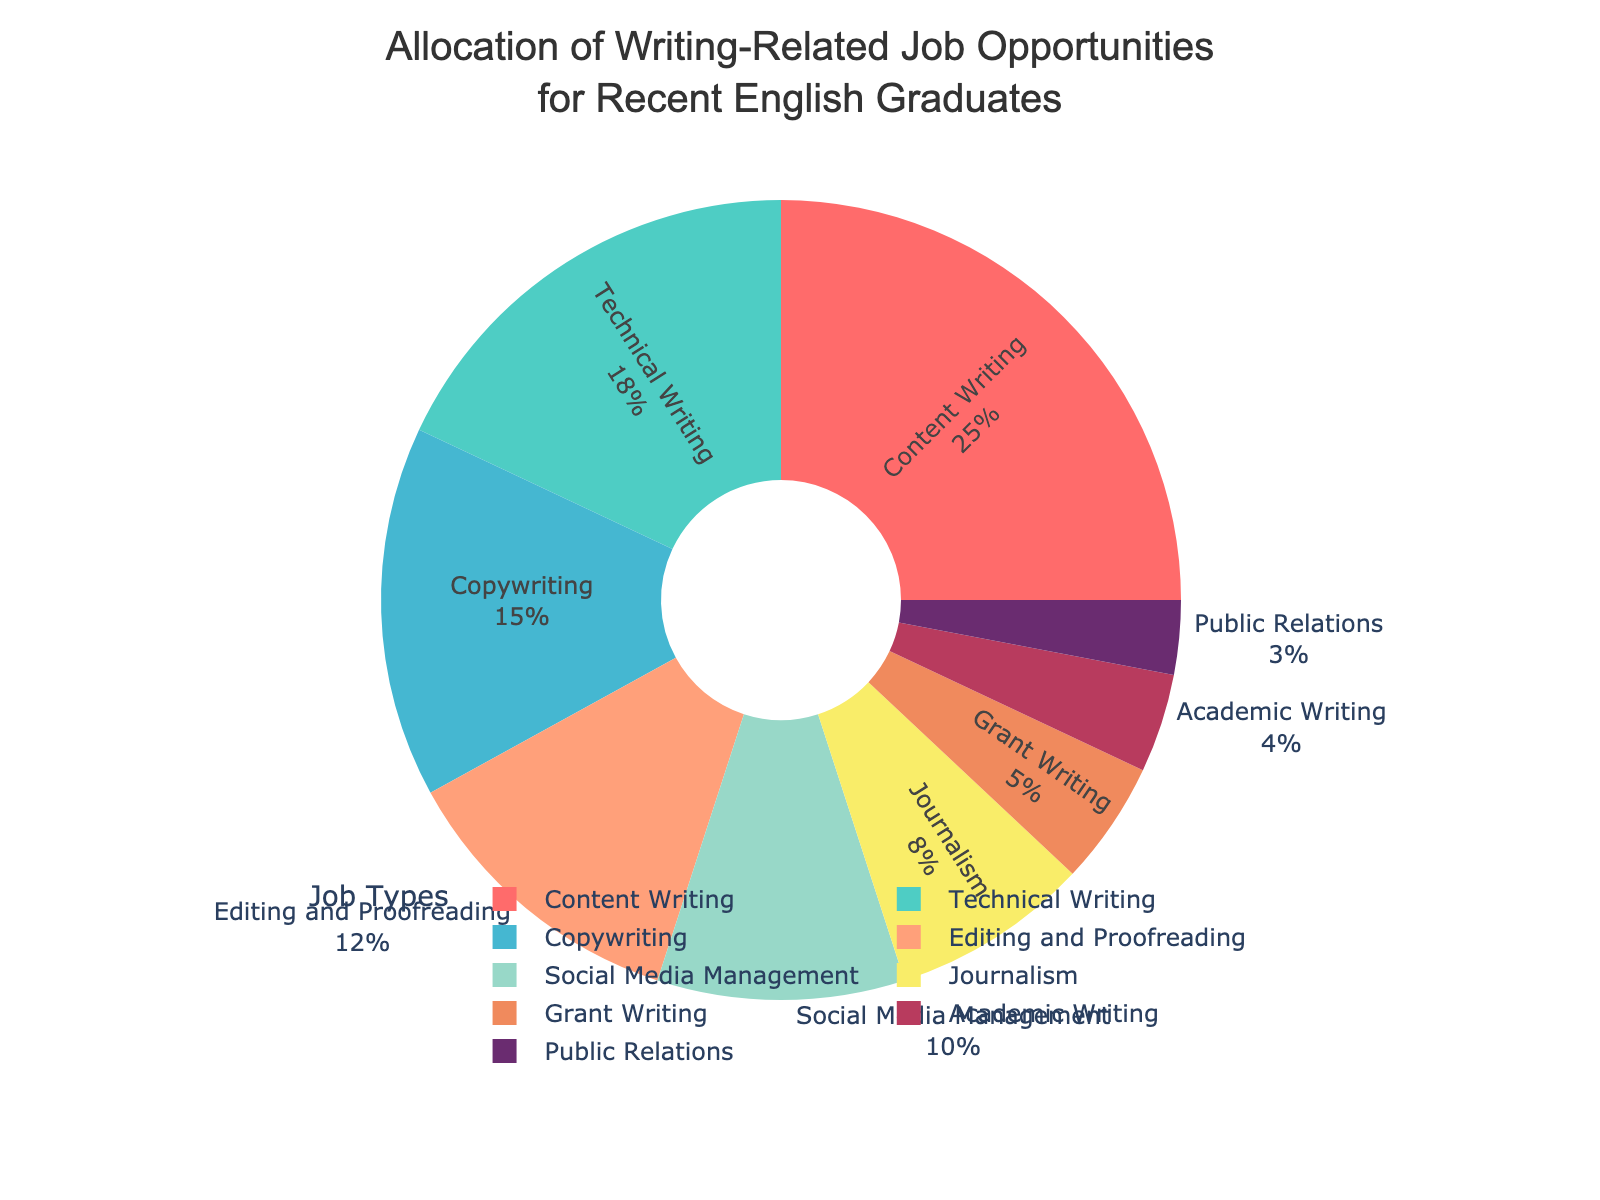Which job type has the highest allocation of opportunities? By looking at the pie chart, the largest segment is visible. The segment labeled "Content Writing" is the largest, indicating that it has the highest allocation.
Answer: Content Writing Which job type has the second highest allocation of opportunities? By observing the pie chart, the second largest segment is clearly labeled "Technical Writing."
Answer: Technical Writing How many job types have an allocation of 10% or more? By examining the pie chart, the segments labeled "Content Writing" (25%), "Technical Writing" (18%), "Copywriting" (15%), and "Editing and Proofreading" (12%) all have allocations of 10% or more. That's 4 job types in total.
Answer: 4 What is the total allocation percentage for jobs in writing and editing (Content Writing + Copywriting + Editing and Proofreading)? Sum the percentages for these job types: Content Writing (25%) + Copywriting (15%) + Editing and Proofreading (12%) = 52%.
Answer: 52% Which job type has the smallest allocation of opportunities? By examining the pie chart, the smallest segment is labeled "Public Relations," indicating that it has the smallest allocation.
Answer: Public Relations Are there more job opportunities in Grant Writing or Academic Writing? By comparing the segments labeled "Grant Writing" and "Academic Writing" on the pie chart, Grant Writing has a larger segment (5%) compared to Academic Writing (4%).
Answer: Grant Writing What is the combined percentage of Social Media Management and Journalism job opportunities? Sum the percentages for Social Media Management (10%) and Journalism (8%) to get a total of 18%.
Answer: 18% Is the allocation for Editing and Proofreading greater than the combined allocation for Grant Writing and Academic Writing? Compare the percentages: Editing and Proofreading is 12%, while the combined percentage for Grant Writing (5%) and Academic Writing (4%) is 9%. So, Editing and Proofreading has a greater allocation.
Answer: Yes, 12% vs 9% Which job types have less than 10% allocation? List them. By looking at the pie chart, the segments labeled "Journalism" (8%), "Grant Writing" (5%), "Academic Writing" (4%), and "Public Relations" (3%) each have allocations less than 10%.
Answer: Journalism, Grant Writing, Academic Writing, Public Relations What percentage of job opportunities do the top three largest job types cover? Sum the percentages for the top three largest job types: Content Writing (25%), Technical Writing (18%), and Copywriting (15%). Summing these gives 25% + 18% + 15% = 58%.
Answer: 58% 